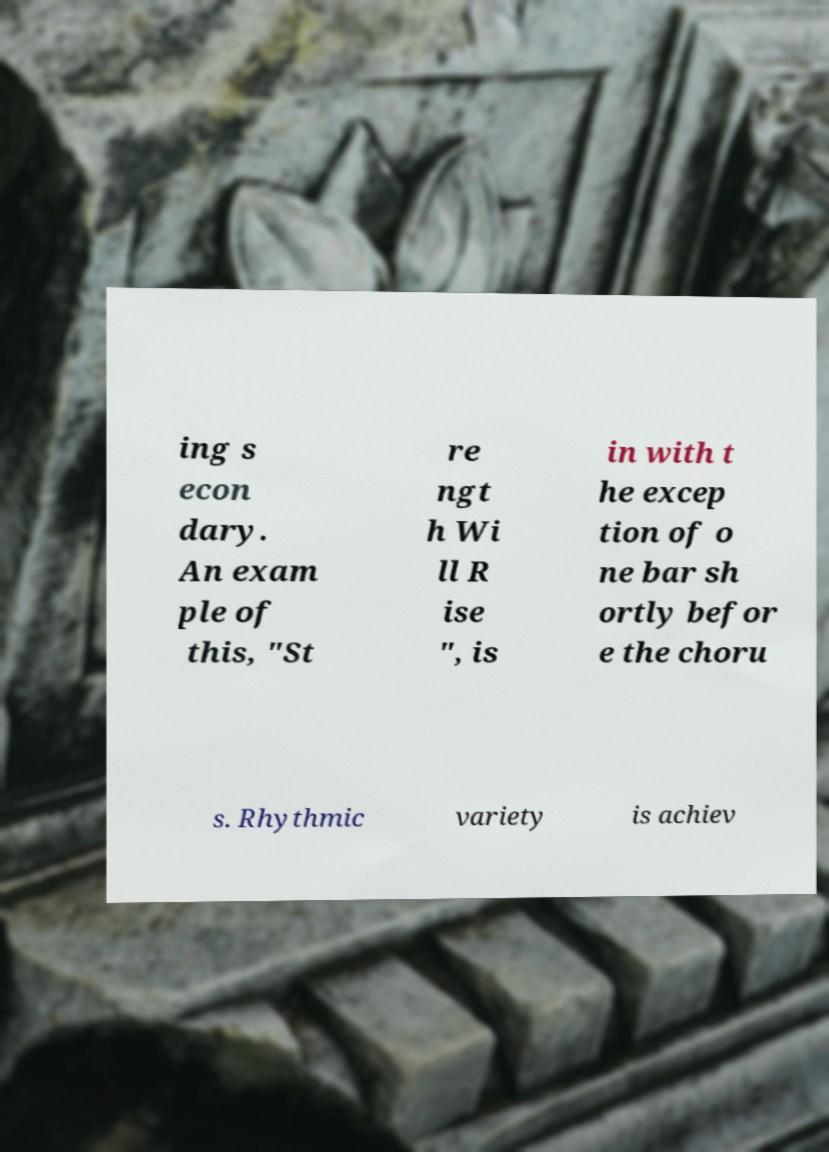Can you read and provide the text displayed in the image?This photo seems to have some interesting text. Can you extract and type it out for me? ing s econ dary. An exam ple of this, "St re ngt h Wi ll R ise ", is in with t he excep tion of o ne bar sh ortly befor e the choru s. Rhythmic variety is achiev 